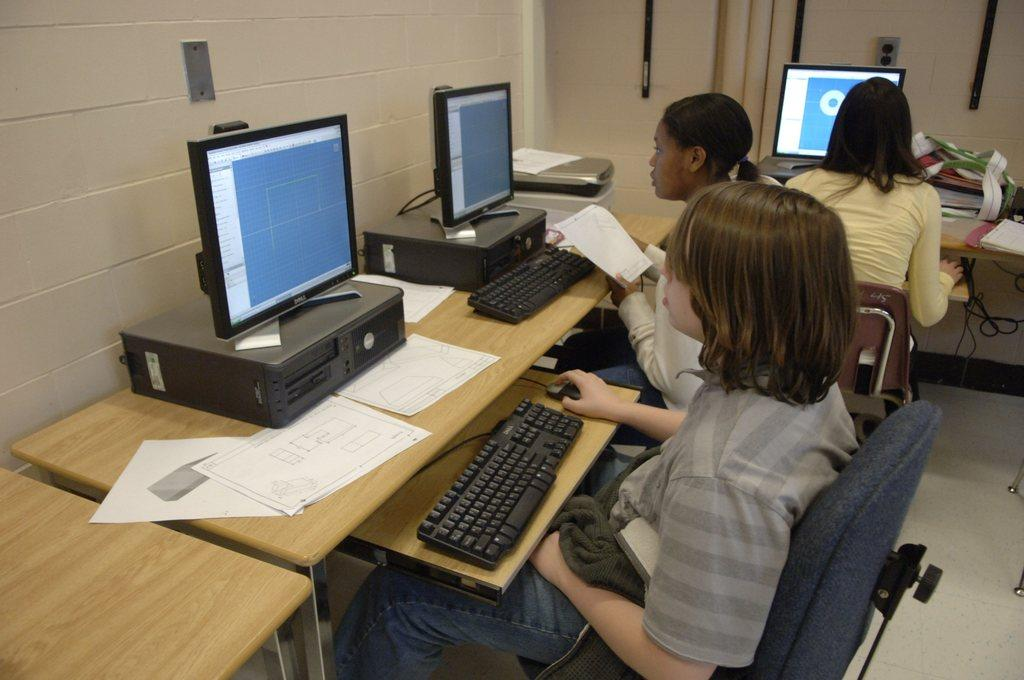How many people are sitting in chairs in the image? There are three members sitting in chairs in the image. What are the members doing in the image? The members are in front of a computer. Where is the computer placed? The computer is placed on a table. What else can be seen on the table? There are papers on the table. What is visible in the background of the image? There is a wall in the background. Can you see any fog in the image? There is no fog visible in the image. Is there a writer present in the image? There is no mention of a writer in the image; the focus is on the three members sitting in chairs and using a computer. 